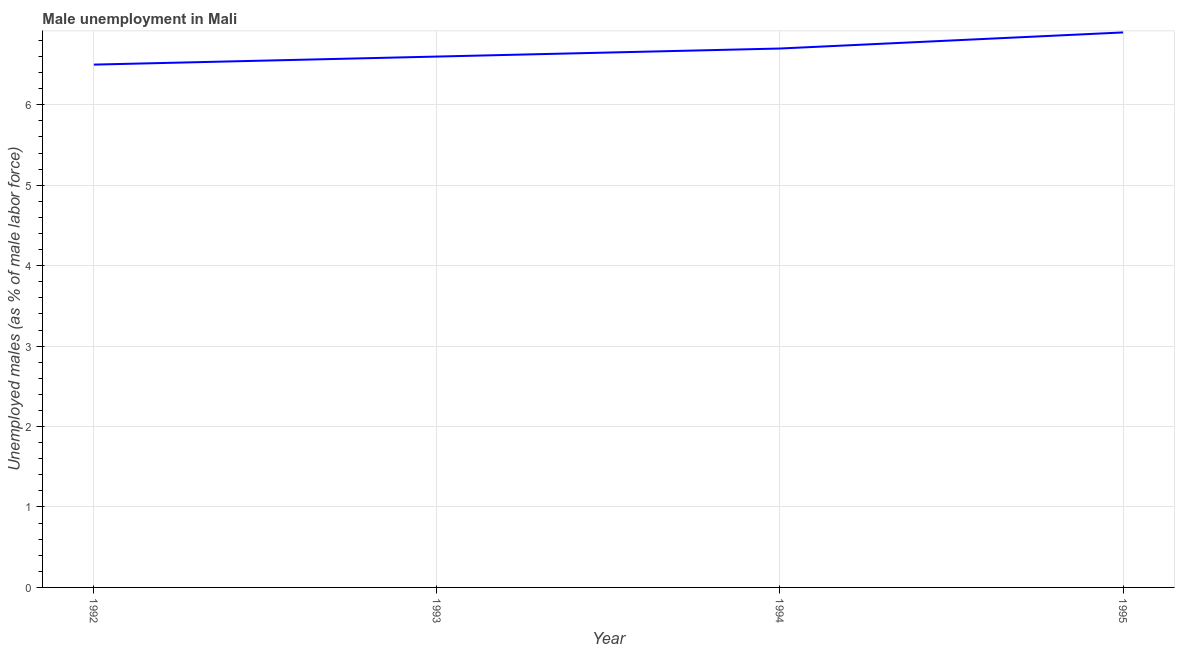What is the unemployed males population in 1993?
Make the answer very short. 6.6. Across all years, what is the maximum unemployed males population?
Your answer should be very brief. 6.9. What is the sum of the unemployed males population?
Offer a very short reply. 26.7. What is the difference between the unemployed males population in 1993 and 1994?
Offer a very short reply. -0.1. What is the average unemployed males population per year?
Provide a succinct answer. 6.67. What is the median unemployed males population?
Provide a short and direct response. 6.65. In how many years, is the unemployed males population greater than 4.4 %?
Your answer should be compact. 4. What is the ratio of the unemployed males population in 1994 to that in 1995?
Give a very brief answer. 0.97. Is the unemployed males population in 1992 less than that in 1994?
Ensure brevity in your answer.  Yes. Is the difference between the unemployed males population in 1994 and 1995 greater than the difference between any two years?
Make the answer very short. No. What is the difference between the highest and the second highest unemployed males population?
Your answer should be very brief. 0.2. Is the sum of the unemployed males population in 1993 and 1994 greater than the maximum unemployed males population across all years?
Your response must be concise. Yes. What is the difference between the highest and the lowest unemployed males population?
Provide a succinct answer. 0.4. Does the unemployed males population monotonically increase over the years?
Offer a terse response. Yes. How many lines are there?
Give a very brief answer. 1. How many years are there in the graph?
Your answer should be very brief. 4. What is the difference between two consecutive major ticks on the Y-axis?
Your response must be concise. 1. Does the graph contain any zero values?
Provide a short and direct response. No. Does the graph contain grids?
Keep it short and to the point. Yes. What is the title of the graph?
Your answer should be compact. Male unemployment in Mali. What is the label or title of the X-axis?
Your answer should be compact. Year. What is the label or title of the Y-axis?
Ensure brevity in your answer.  Unemployed males (as % of male labor force). What is the Unemployed males (as % of male labor force) of 1993?
Offer a very short reply. 6.6. What is the Unemployed males (as % of male labor force) in 1994?
Ensure brevity in your answer.  6.7. What is the Unemployed males (as % of male labor force) in 1995?
Keep it short and to the point. 6.9. What is the difference between the Unemployed males (as % of male labor force) in 1992 and 1993?
Offer a terse response. -0.1. What is the difference between the Unemployed males (as % of male labor force) in 1992 and 1995?
Your response must be concise. -0.4. What is the difference between the Unemployed males (as % of male labor force) in 1993 and 1994?
Give a very brief answer. -0.1. What is the difference between the Unemployed males (as % of male labor force) in 1994 and 1995?
Keep it short and to the point. -0.2. What is the ratio of the Unemployed males (as % of male labor force) in 1992 to that in 1993?
Provide a short and direct response. 0.98. What is the ratio of the Unemployed males (as % of male labor force) in 1992 to that in 1994?
Provide a short and direct response. 0.97. What is the ratio of the Unemployed males (as % of male labor force) in 1992 to that in 1995?
Offer a terse response. 0.94. What is the ratio of the Unemployed males (as % of male labor force) in 1993 to that in 1994?
Keep it short and to the point. 0.98. What is the ratio of the Unemployed males (as % of male labor force) in 1994 to that in 1995?
Ensure brevity in your answer.  0.97. 